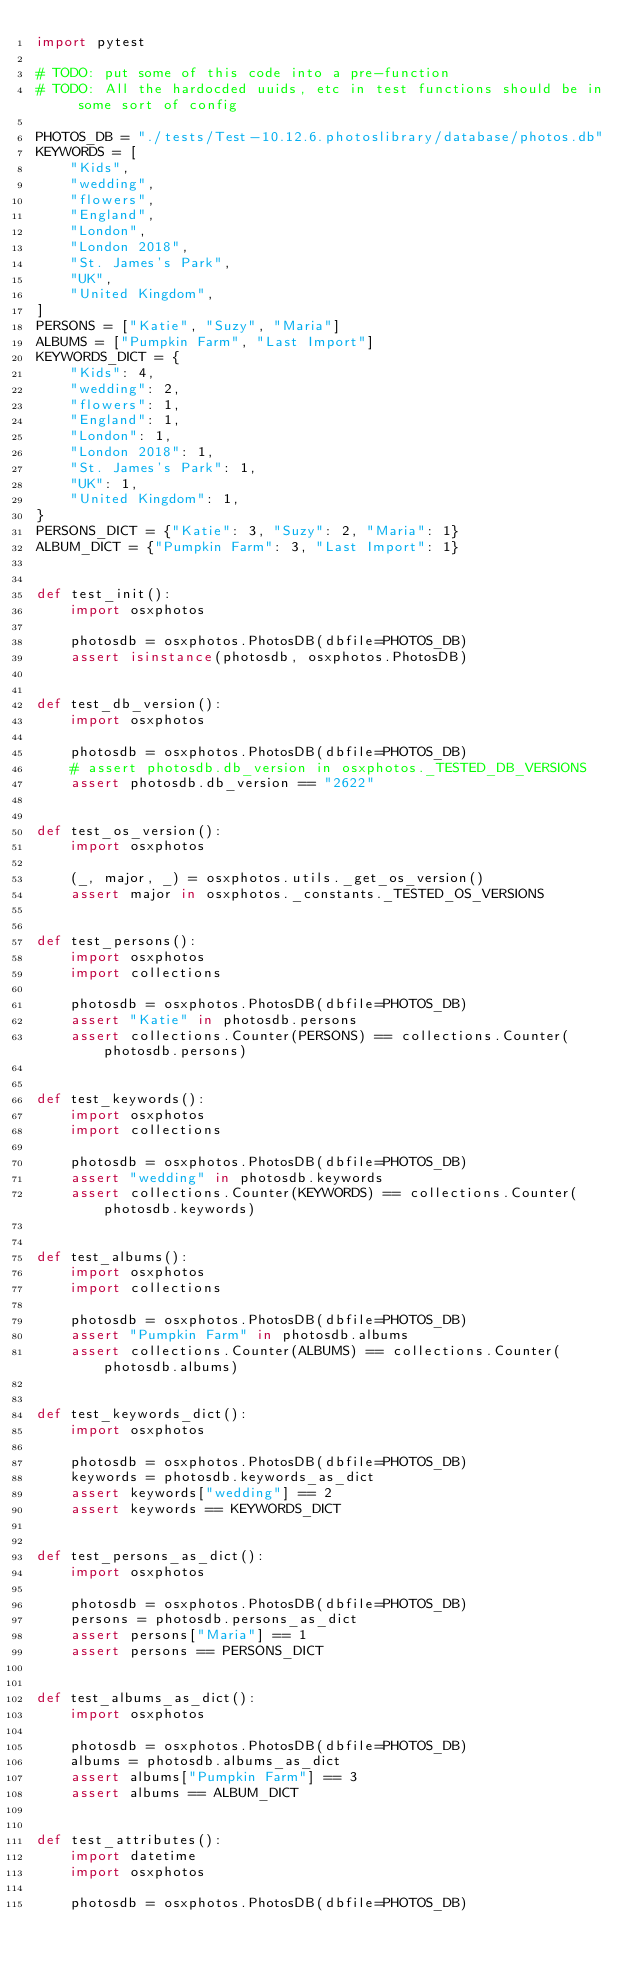<code> <loc_0><loc_0><loc_500><loc_500><_Python_>import pytest

# TODO: put some of this code into a pre-function
# TODO: All the hardocded uuids, etc in test functions should be in some sort of config

PHOTOS_DB = "./tests/Test-10.12.6.photoslibrary/database/photos.db"
KEYWORDS = [
    "Kids",
    "wedding",
    "flowers",
    "England",
    "London",
    "London 2018",
    "St. James's Park",
    "UK",
    "United Kingdom",
]
PERSONS = ["Katie", "Suzy", "Maria"]
ALBUMS = ["Pumpkin Farm", "Last Import"]
KEYWORDS_DICT = {
    "Kids": 4,
    "wedding": 2,
    "flowers": 1,
    "England": 1,
    "London": 1,
    "London 2018": 1,
    "St. James's Park": 1,
    "UK": 1,
    "United Kingdom": 1,
}
PERSONS_DICT = {"Katie": 3, "Suzy": 2, "Maria": 1}
ALBUM_DICT = {"Pumpkin Farm": 3, "Last Import": 1}


def test_init():
    import osxphotos

    photosdb = osxphotos.PhotosDB(dbfile=PHOTOS_DB)
    assert isinstance(photosdb, osxphotos.PhotosDB)


def test_db_version():
    import osxphotos

    photosdb = osxphotos.PhotosDB(dbfile=PHOTOS_DB)
    # assert photosdb.db_version in osxphotos._TESTED_DB_VERSIONS
    assert photosdb.db_version == "2622"


def test_os_version():
    import osxphotos

    (_, major, _) = osxphotos.utils._get_os_version()
    assert major in osxphotos._constants._TESTED_OS_VERSIONS


def test_persons():
    import osxphotos
    import collections

    photosdb = osxphotos.PhotosDB(dbfile=PHOTOS_DB)
    assert "Katie" in photosdb.persons
    assert collections.Counter(PERSONS) == collections.Counter(photosdb.persons)


def test_keywords():
    import osxphotos
    import collections

    photosdb = osxphotos.PhotosDB(dbfile=PHOTOS_DB)
    assert "wedding" in photosdb.keywords
    assert collections.Counter(KEYWORDS) == collections.Counter(photosdb.keywords)


def test_albums():
    import osxphotos
    import collections

    photosdb = osxphotos.PhotosDB(dbfile=PHOTOS_DB)
    assert "Pumpkin Farm" in photosdb.albums
    assert collections.Counter(ALBUMS) == collections.Counter(photosdb.albums)


def test_keywords_dict():
    import osxphotos

    photosdb = osxphotos.PhotosDB(dbfile=PHOTOS_DB)
    keywords = photosdb.keywords_as_dict
    assert keywords["wedding"] == 2
    assert keywords == KEYWORDS_DICT


def test_persons_as_dict():
    import osxphotos

    photosdb = osxphotos.PhotosDB(dbfile=PHOTOS_DB)
    persons = photosdb.persons_as_dict
    assert persons["Maria"] == 1
    assert persons == PERSONS_DICT


def test_albums_as_dict():
    import osxphotos

    photosdb = osxphotos.PhotosDB(dbfile=PHOTOS_DB)
    albums = photosdb.albums_as_dict
    assert albums["Pumpkin Farm"] == 3
    assert albums == ALBUM_DICT


def test_attributes():
    import datetime
    import osxphotos

    photosdb = osxphotos.PhotosDB(dbfile=PHOTOS_DB)</code> 